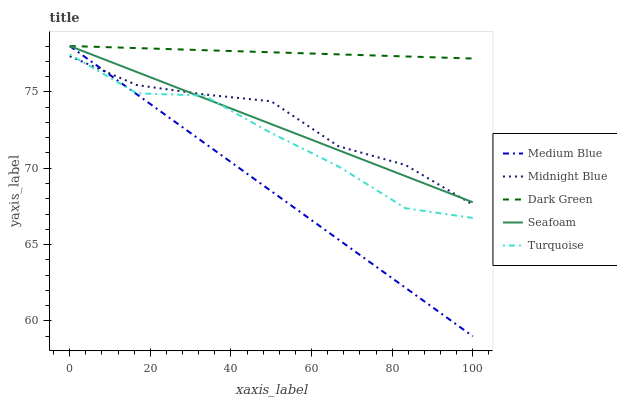Does Medium Blue have the minimum area under the curve?
Answer yes or no. Yes. Does Dark Green have the maximum area under the curve?
Answer yes or no. Yes. Does Turquoise have the minimum area under the curve?
Answer yes or no. No. Does Turquoise have the maximum area under the curve?
Answer yes or no. No. Is Medium Blue the smoothest?
Answer yes or no. Yes. Is Turquoise the roughest?
Answer yes or no. Yes. Is Turquoise the smoothest?
Answer yes or no. No. Is Medium Blue the roughest?
Answer yes or no. No. Does Medium Blue have the lowest value?
Answer yes or no. Yes. Does Turquoise have the lowest value?
Answer yes or no. No. Does Dark Green have the highest value?
Answer yes or no. Yes. Does Turquoise have the highest value?
Answer yes or no. No. Is Turquoise less than Dark Green?
Answer yes or no. Yes. Is Dark Green greater than Turquoise?
Answer yes or no. Yes. Does Seafoam intersect Midnight Blue?
Answer yes or no. Yes. Is Seafoam less than Midnight Blue?
Answer yes or no. No. Is Seafoam greater than Midnight Blue?
Answer yes or no. No. Does Turquoise intersect Dark Green?
Answer yes or no. No. 